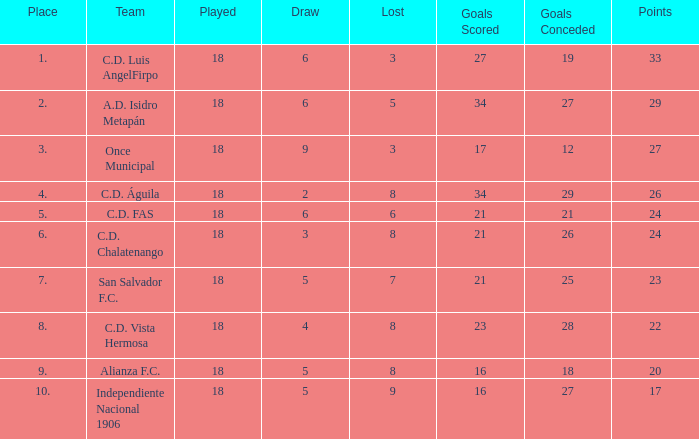What is the count of goals allowed with a player exceeding 18 appearances? 0.0. 